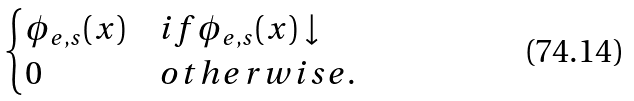Convert formula to latex. <formula><loc_0><loc_0><loc_500><loc_500>\begin{cases} \phi _ { e , s } ( x ) & i f \phi _ { e , s } ( x ) \downarrow \\ 0 & o t h e r w i s e . \end{cases}</formula> 